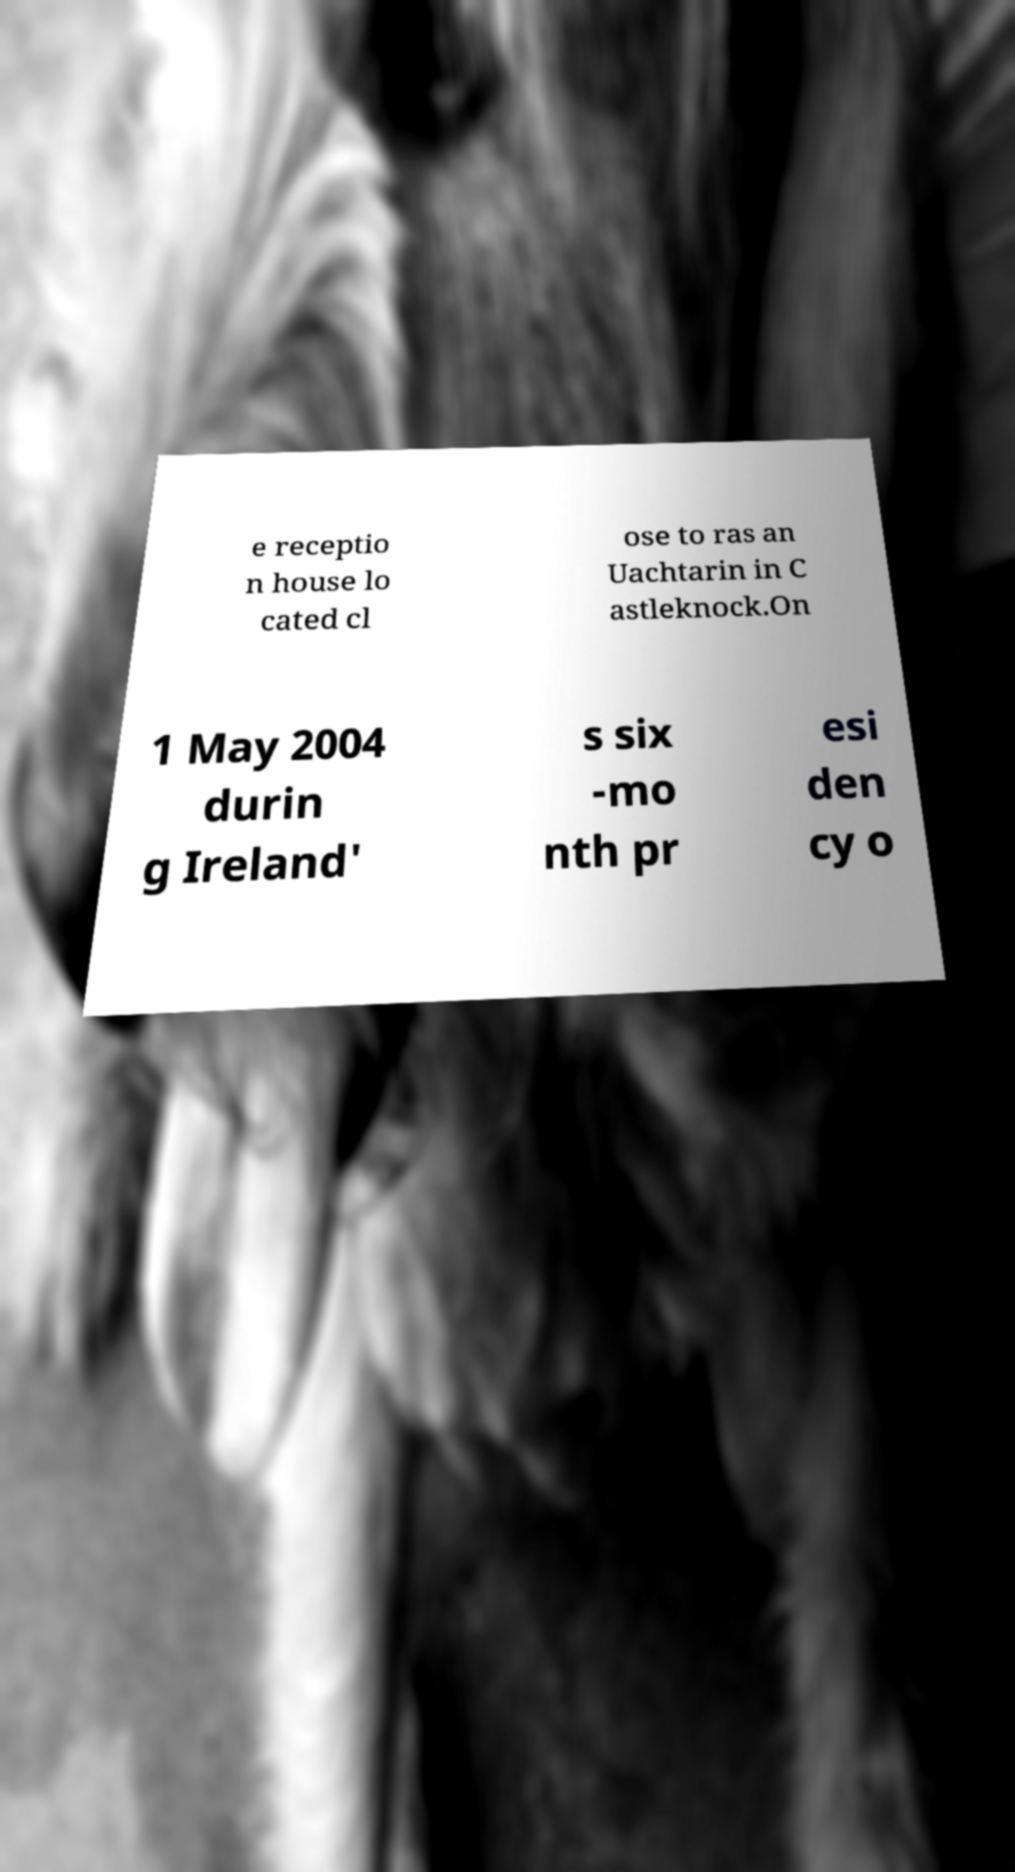What messages or text are displayed in this image? I need them in a readable, typed format. e receptio n house lo cated cl ose to ras an Uachtarin in C astleknock.On 1 May 2004 durin g Ireland' s six -mo nth pr esi den cy o 